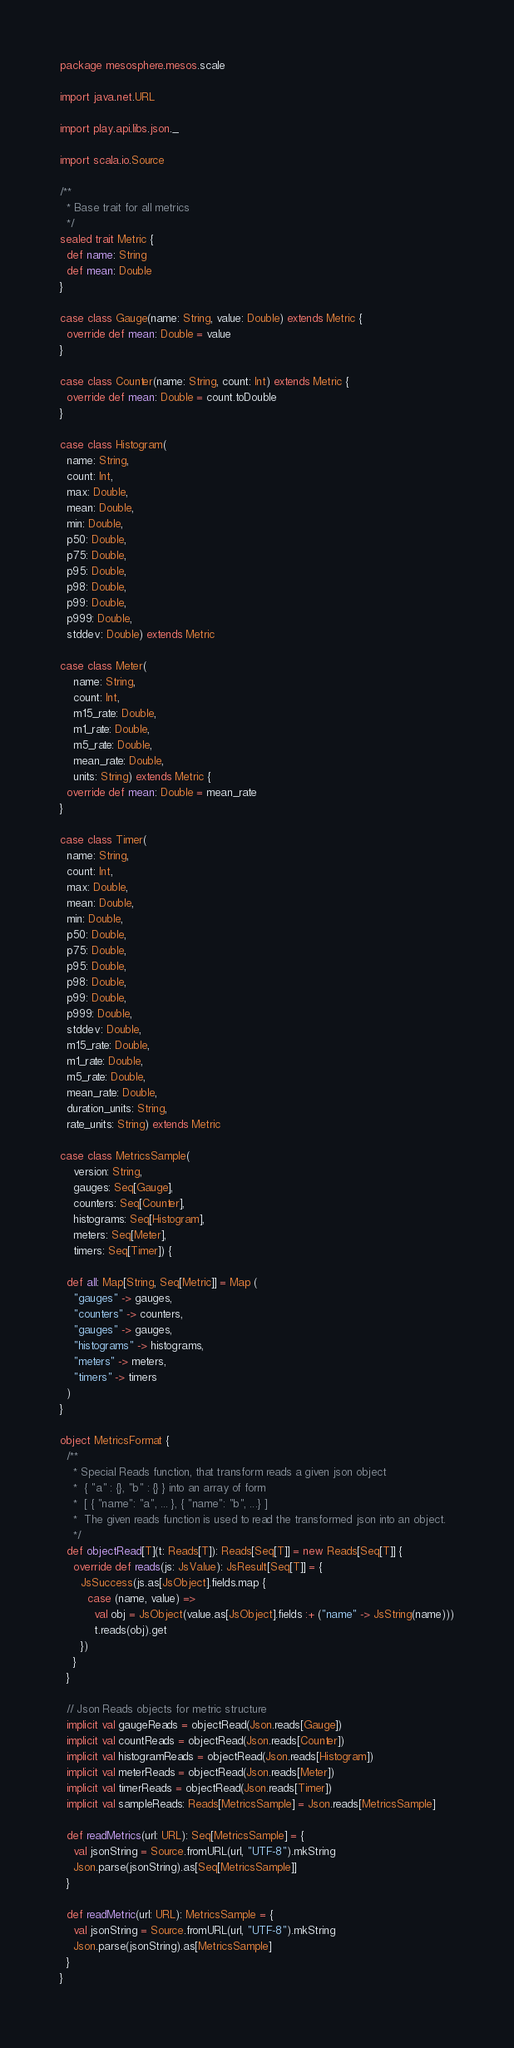<code> <loc_0><loc_0><loc_500><loc_500><_Scala_>package mesosphere.mesos.scale

import java.net.URL

import play.api.libs.json._

import scala.io.Source

/**
  * Base trait for all metrics
  */
sealed trait Metric {
  def name: String
  def mean: Double
}

case class Gauge(name: String, value: Double) extends Metric {
  override def mean: Double = value
}

case class Counter(name: String, count: Int) extends Metric {
  override def mean: Double = count.toDouble
}

case class Histogram(
  name: String,
  count: Int,
  max: Double,
  mean: Double,
  min: Double,
  p50: Double,
  p75: Double,
  p95: Double,
  p98: Double,
  p99: Double,
  p999: Double,
  stddev: Double) extends Metric

case class Meter(
    name: String,
    count: Int,
    m15_rate: Double,
    m1_rate: Double,
    m5_rate: Double,
    mean_rate: Double,
    units: String) extends Metric {
  override def mean: Double = mean_rate
}

case class Timer(
  name: String,
  count: Int,
  max: Double,
  mean: Double,
  min: Double,
  p50: Double,
  p75: Double,
  p95: Double,
  p98: Double,
  p99: Double,
  p999: Double,
  stddev: Double,
  m15_rate: Double,
  m1_rate: Double,
  m5_rate: Double,
  mean_rate: Double,
  duration_units: String,
  rate_units: String) extends Metric

case class MetricsSample(
    version: String,
    gauges: Seq[Gauge],
    counters: Seq[Counter],
    histograms: Seq[Histogram],
    meters: Seq[Meter],
    timers: Seq[Timer]) {

  def all: Map[String, Seq[Metric]] = Map (
    "gauges" -> gauges,
    "counters" -> counters,
    "gauges" -> gauges,
    "histograms" -> histograms,
    "meters" -> meters,
    "timers" -> timers
  )
}

object MetricsFormat {
  /**
    * Special Reads function, that transform reads a given json object
    *  { "a" : {}, "b" : {} } into an array of form
    *  [ { "name": "a", ... }, { "name": "b", ...} ]
    *  The given reads function is used to read the transformed json into an object.
    */
  def objectRead[T](t: Reads[T]): Reads[Seq[T]] = new Reads[Seq[T]] {
    override def reads(js: JsValue): JsResult[Seq[T]] = {
      JsSuccess(js.as[JsObject].fields.map {
        case (name, value) =>
          val obj = JsObject(value.as[JsObject].fields :+ ("name" -> JsString(name)))
          t.reads(obj).get
      })
    }
  }

  // Json Reads objects for metric structure
  implicit val gaugeReads = objectRead(Json.reads[Gauge])
  implicit val countReads = objectRead(Json.reads[Counter])
  implicit val histogramReads = objectRead(Json.reads[Histogram])
  implicit val meterReads = objectRead(Json.reads[Meter])
  implicit val timerReads = objectRead(Json.reads[Timer])
  implicit val sampleReads: Reads[MetricsSample] = Json.reads[MetricsSample]

  def readMetrics(url: URL): Seq[MetricsSample] = {
    val jsonString = Source.fromURL(url, "UTF-8").mkString
    Json.parse(jsonString).as[Seq[MetricsSample]]
  }

  def readMetric(url: URL): MetricsSample = {
    val jsonString = Source.fromURL(url, "UTF-8").mkString
    Json.parse(jsonString).as[MetricsSample]
  }
}
</code> 